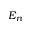Convert formula to latex. <formula><loc_0><loc_0><loc_500><loc_500>E _ { n }</formula> 